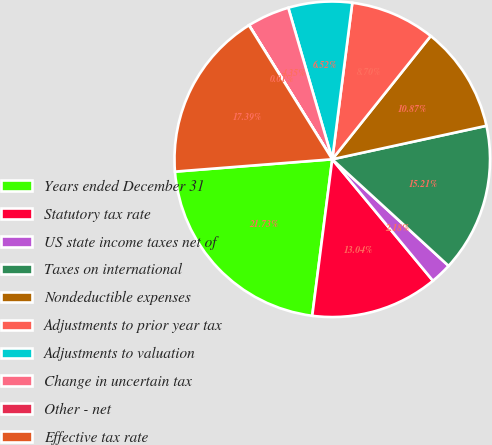Convert chart. <chart><loc_0><loc_0><loc_500><loc_500><pie_chart><fcel>Years ended December 31<fcel>Statutory tax rate<fcel>US state income taxes net of<fcel>Taxes on international<fcel>Nondeductible expenses<fcel>Adjustments to prior year tax<fcel>Adjustments to valuation<fcel>Change in uncertain tax<fcel>Other - net<fcel>Effective tax rate<nl><fcel>21.73%<fcel>13.04%<fcel>2.18%<fcel>15.21%<fcel>10.87%<fcel>8.7%<fcel>6.52%<fcel>4.35%<fcel>0.01%<fcel>17.39%<nl></chart> 